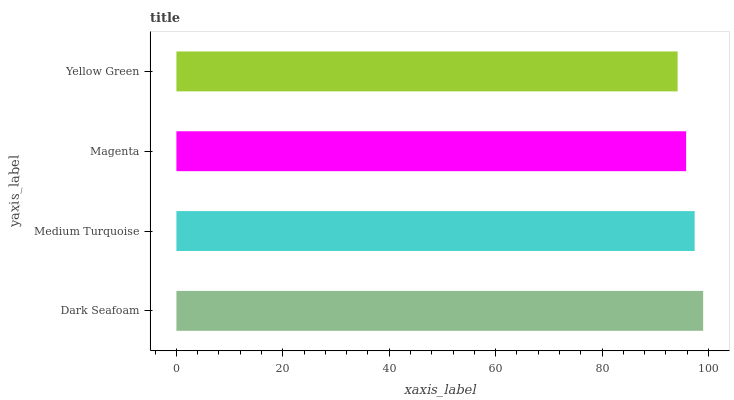Is Yellow Green the minimum?
Answer yes or no. Yes. Is Dark Seafoam the maximum?
Answer yes or no. Yes. Is Medium Turquoise the minimum?
Answer yes or no. No. Is Medium Turquoise the maximum?
Answer yes or no. No. Is Dark Seafoam greater than Medium Turquoise?
Answer yes or no. Yes. Is Medium Turquoise less than Dark Seafoam?
Answer yes or no. Yes. Is Medium Turquoise greater than Dark Seafoam?
Answer yes or no. No. Is Dark Seafoam less than Medium Turquoise?
Answer yes or no. No. Is Medium Turquoise the high median?
Answer yes or no. Yes. Is Magenta the low median?
Answer yes or no. Yes. Is Magenta the high median?
Answer yes or no. No. Is Dark Seafoam the low median?
Answer yes or no. No. 